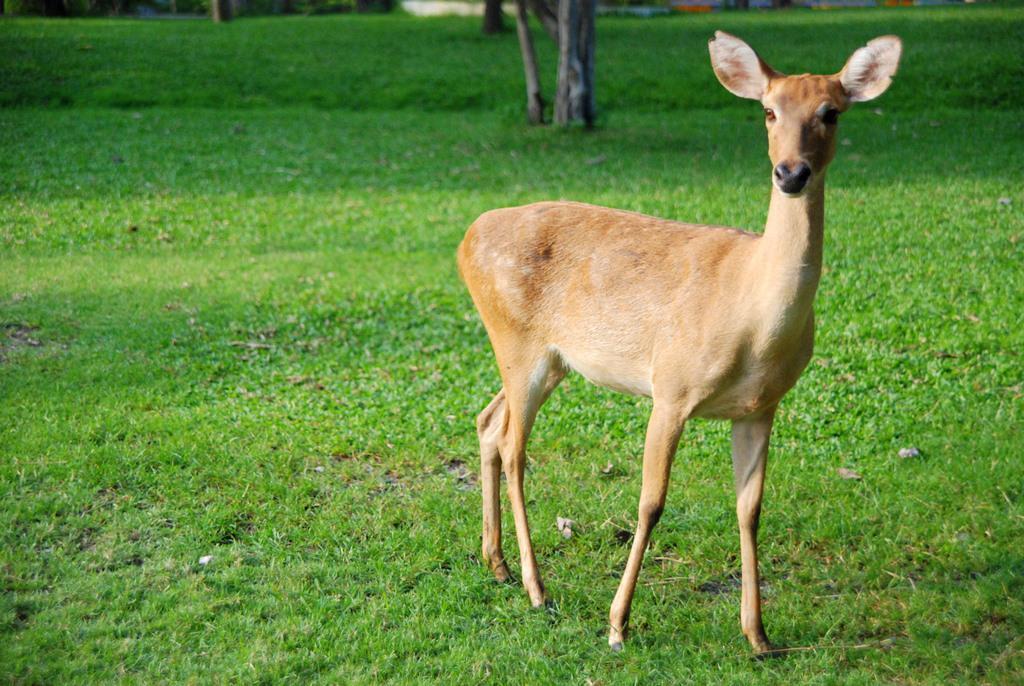Describe this image in one or two sentences. In this picture we can see deer on the grass. In the background of the image we can see tree trunks. 